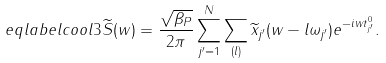Convert formula to latex. <formula><loc_0><loc_0><loc_500><loc_500>\ e q l a b e l { c o o l 3 } \widetilde { S } ( w ) = \frac { \sqrt { \beta _ { P } } } { 2 \pi } \sum _ { j ^ { \prime } = 1 } ^ { N } \sum _ { ( l ) } \widetilde { x } _ { j ^ { \prime } } ( w - l \omega _ { j ^ { \prime } } ) e ^ { - i w t _ { j ^ { \prime } } ^ { 0 } } .</formula> 